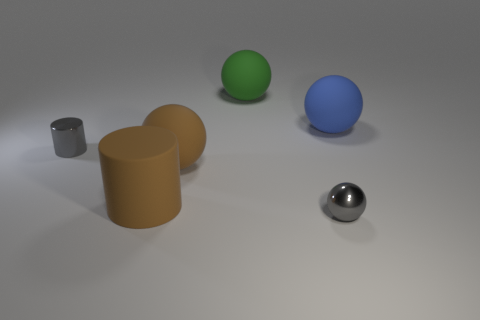Add 2 yellow rubber blocks. How many objects exist? 8 Subtract all cylinders. How many objects are left? 4 Add 6 large rubber cylinders. How many large rubber cylinders are left? 7 Add 1 gray balls. How many gray balls exist? 2 Subtract 1 brown spheres. How many objects are left? 5 Subtract all large cyan shiny blocks. Subtract all matte things. How many objects are left? 2 